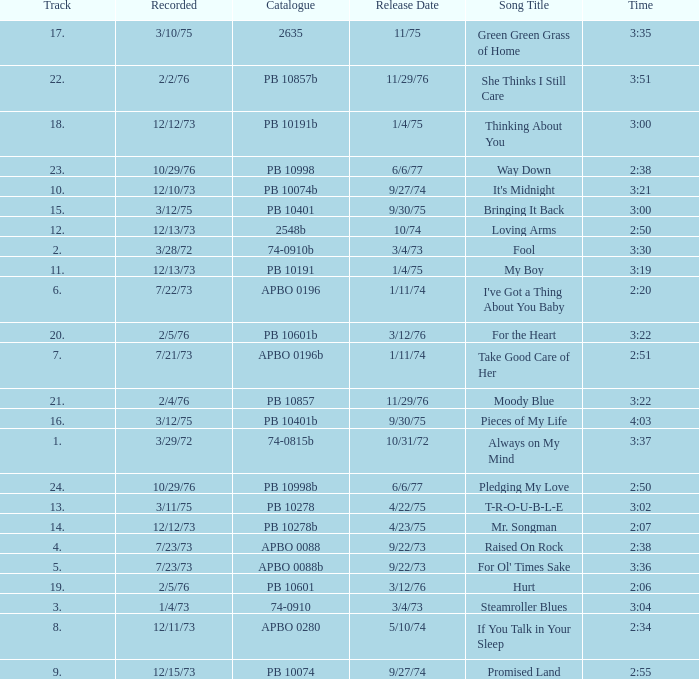Tell me the track that has the catalogue of apbo 0280 8.0. 